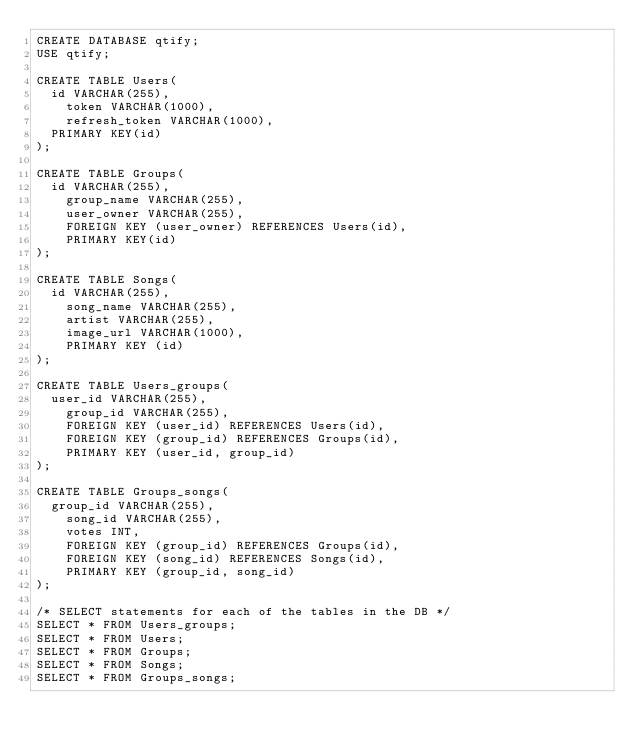Convert code to text. <code><loc_0><loc_0><loc_500><loc_500><_SQL_>CREATE DATABASE qtify;
USE qtify;

CREATE TABLE Users(
	id VARCHAR(255),
    token VARCHAR(1000),
    refresh_token VARCHAR(1000),
	PRIMARY KEY(id)
);

CREATE TABLE Groups(
	id VARCHAR(255),
    group_name VARCHAR(255),
    user_owner VARCHAR(255),
    FOREIGN KEY (user_owner) REFERENCES Users(id),
    PRIMARY KEY(id)
);

CREATE TABLE Songs(
	id VARCHAR(255),
    song_name VARCHAR(255),
    artist VARCHAR(255),
    image_url VARCHAR(1000),
    PRIMARY KEY (id)
);

CREATE TABLE Users_groups(
	user_id VARCHAR(255),
    group_id VARCHAR(255),
    FOREIGN KEY (user_id) REFERENCES Users(id),
    FOREIGN KEY (group_id) REFERENCES Groups(id),
    PRIMARY KEY (user_id, group_id)
);

CREATE TABLE Groups_songs(
	group_id VARCHAR(255),
    song_id VARCHAR(255),
    votes INT,
    FOREIGN KEY (group_id) REFERENCES Groups(id),
    FOREIGN KEY (song_id) REFERENCES Songs(id),
    PRIMARY KEY (group_id, song_id)
);

/* SELECT statements for each of the tables in the DB */
SELECT * FROM Users_groups;
SELECT * FROM Users;
SELECT * FROM Groups;
SELECT * FROM Songs;
SELECT * FROM Groups_songs;</code> 